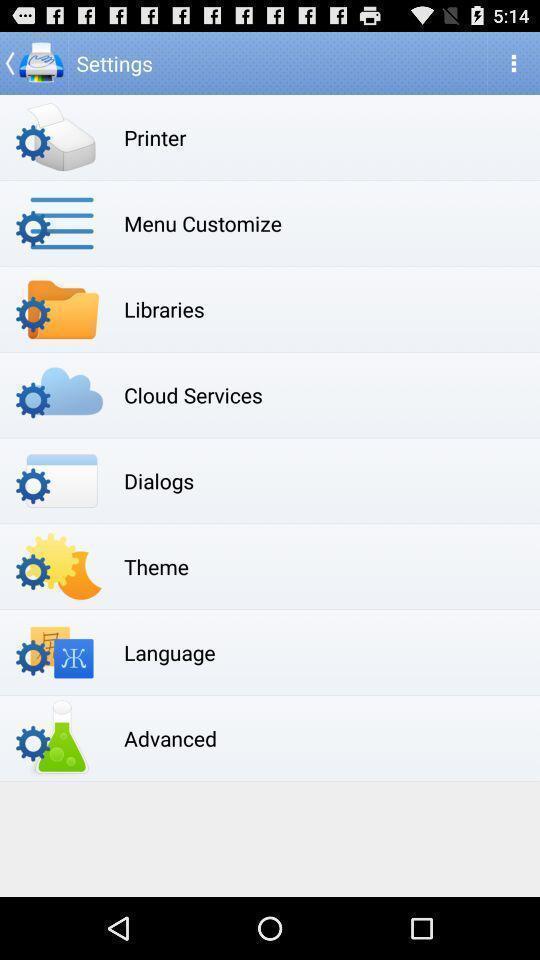Explain what's happening in this screen capture. Page displaying the various options of settings. 